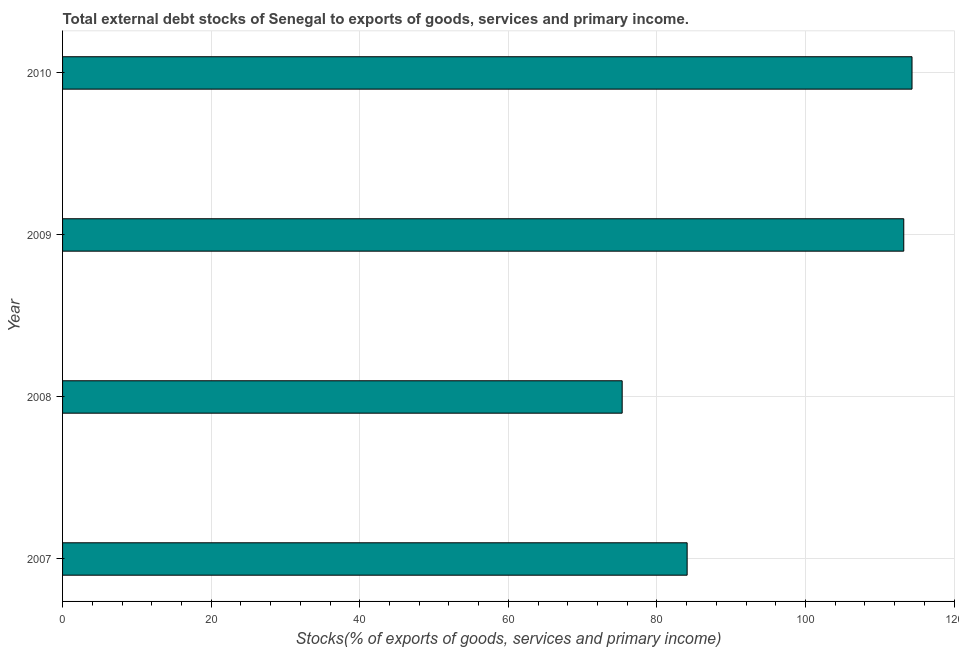What is the title of the graph?
Give a very brief answer. Total external debt stocks of Senegal to exports of goods, services and primary income. What is the label or title of the X-axis?
Offer a terse response. Stocks(% of exports of goods, services and primary income). What is the label or title of the Y-axis?
Provide a succinct answer. Year. What is the external debt stocks in 2009?
Your answer should be compact. 113.24. Across all years, what is the maximum external debt stocks?
Offer a terse response. 114.35. Across all years, what is the minimum external debt stocks?
Keep it short and to the point. 75.33. What is the sum of the external debt stocks?
Keep it short and to the point. 386.99. What is the difference between the external debt stocks in 2007 and 2009?
Make the answer very short. -29.16. What is the average external debt stocks per year?
Your answer should be compact. 96.75. What is the median external debt stocks?
Ensure brevity in your answer.  98.66. Do a majority of the years between 2008 and 2007 (inclusive) have external debt stocks greater than 64 %?
Provide a succinct answer. No. What is the ratio of the external debt stocks in 2007 to that in 2009?
Offer a terse response. 0.74. Is the difference between the external debt stocks in 2009 and 2010 greater than the difference between any two years?
Make the answer very short. No. What is the difference between the highest and the second highest external debt stocks?
Keep it short and to the point. 1.11. Is the sum of the external debt stocks in 2007 and 2010 greater than the maximum external debt stocks across all years?
Keep it short and to the point. Yes. What is the difference between the highest and the lowest external debt stocks?
Make the answer very short. 39.02. In how many years, is the external debt stocks greater than the average external debt stocks taken over all years?
Make the answer very short. 2. How many bars are there?
Offer a very short reply. 4. What is the difference between two consecutive major ticks on the X-axis?
Keep it short and to the point. 20. Are the values on the major ticks of X-axis written in scientific E-notation?
Provide a succinct answer. No. What is the Stocks(% of exports of goods, services and primary income) of 2007?
Provide a succinct answer. 84.08. What is the Stocks(% of exports of goods, services and primary income) of 2008?
Your answer should be very brief. 75.33. What is the Stocks(% of exports of goods, services and primary income) in 2009?
Make the answer very short. 113.24. What is the Stocks(% of exports of goods, services and primary income) of 2010?
Give a very brief answer. 114.35. What is the difference between the Stocks(% of exports of goods, services and primary income) in 2007 and 2008?
Offer a terse response. 8.75. What is the difference between the Stocks(% of exports of goods, services and primary income) in 2007 and 2009?
Provide a short and direct response. -29.16. What is the difference between the Stocks(% of exports of goods, services and primary income) in 2007 and 2010?
Offer a terse response. -30.27. What is the difference between the Stocks(% of exports of goods, services and primary income) in 2008 and 2009?
Make the answer very short. -37.91. What is the difference between the Stocks(% of exports of goods, services and primary income) in 2008 and 2010?
Your response must be concise. -39.02. What is the difference between the Stocks(% of exports of goods, services and primary income) in 2009 and 2010?
Keep it short and to the point. -1.11. What is the ratio of the Stocks(% of exports of goods, services and primary income) in 2007 to that in 2008?
Your answer should be compact. 1.12. What is the ratio of the Stocks(% of exports of goods, services and primary income) in 2007 to that in 2009?
Provide a succinct answer. 0.74. What is the ratio of the Stocks(% of exports of goods, services and primary income) in 2007 to that in 2010?
Provide a succinct answer. 0.73. What is the ratio of the Stocks(% of exports of goods, services and primary income) in 2008 to that in 2009?
Keep it short and to the point. 0.67. What is the ratio of the Stocks(% of exports of goods, services and primary income) in 2008 to that in 2010?
Give a very brief answer. 0.66. What is the ratio of the Stocks(% of exports of goods, services and primary income) in 2009 to that in 2010?
Give a very brief answer. 0.99. 